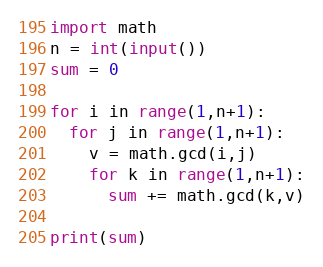<code> <loc_0><loc_0><loc_500><loc_500><_Python_>import math
n = int(input())
sum = 0

for i in range(1,n+1):
  for j in range(1,n+1):
    v = math.gcd(i,j)
    for k in range(1,n+1):
      sum += math.gcd(k,v)

print(sum)</code> 